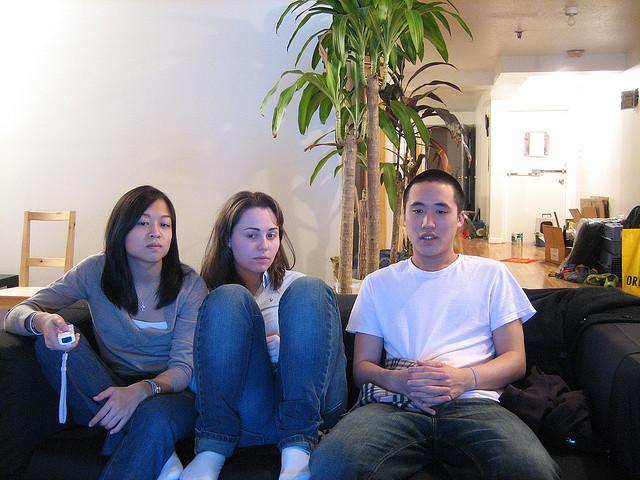What is laying on the sofa next to the man?
Quick response, please. Woman. Who is holding the controller?
Write a very short answer. Girl on left. Is the tree artificial?
Give a very brief answer. No. What are the flowers on the right side of the picture?
Write a very short answer. No flowers. Are they happy?
Give a very brief answer. No. Is everyone in this photo wearing pants?
Keep it brief. Yes. What video game system are they playing?
Write a very short answer. Wii. 